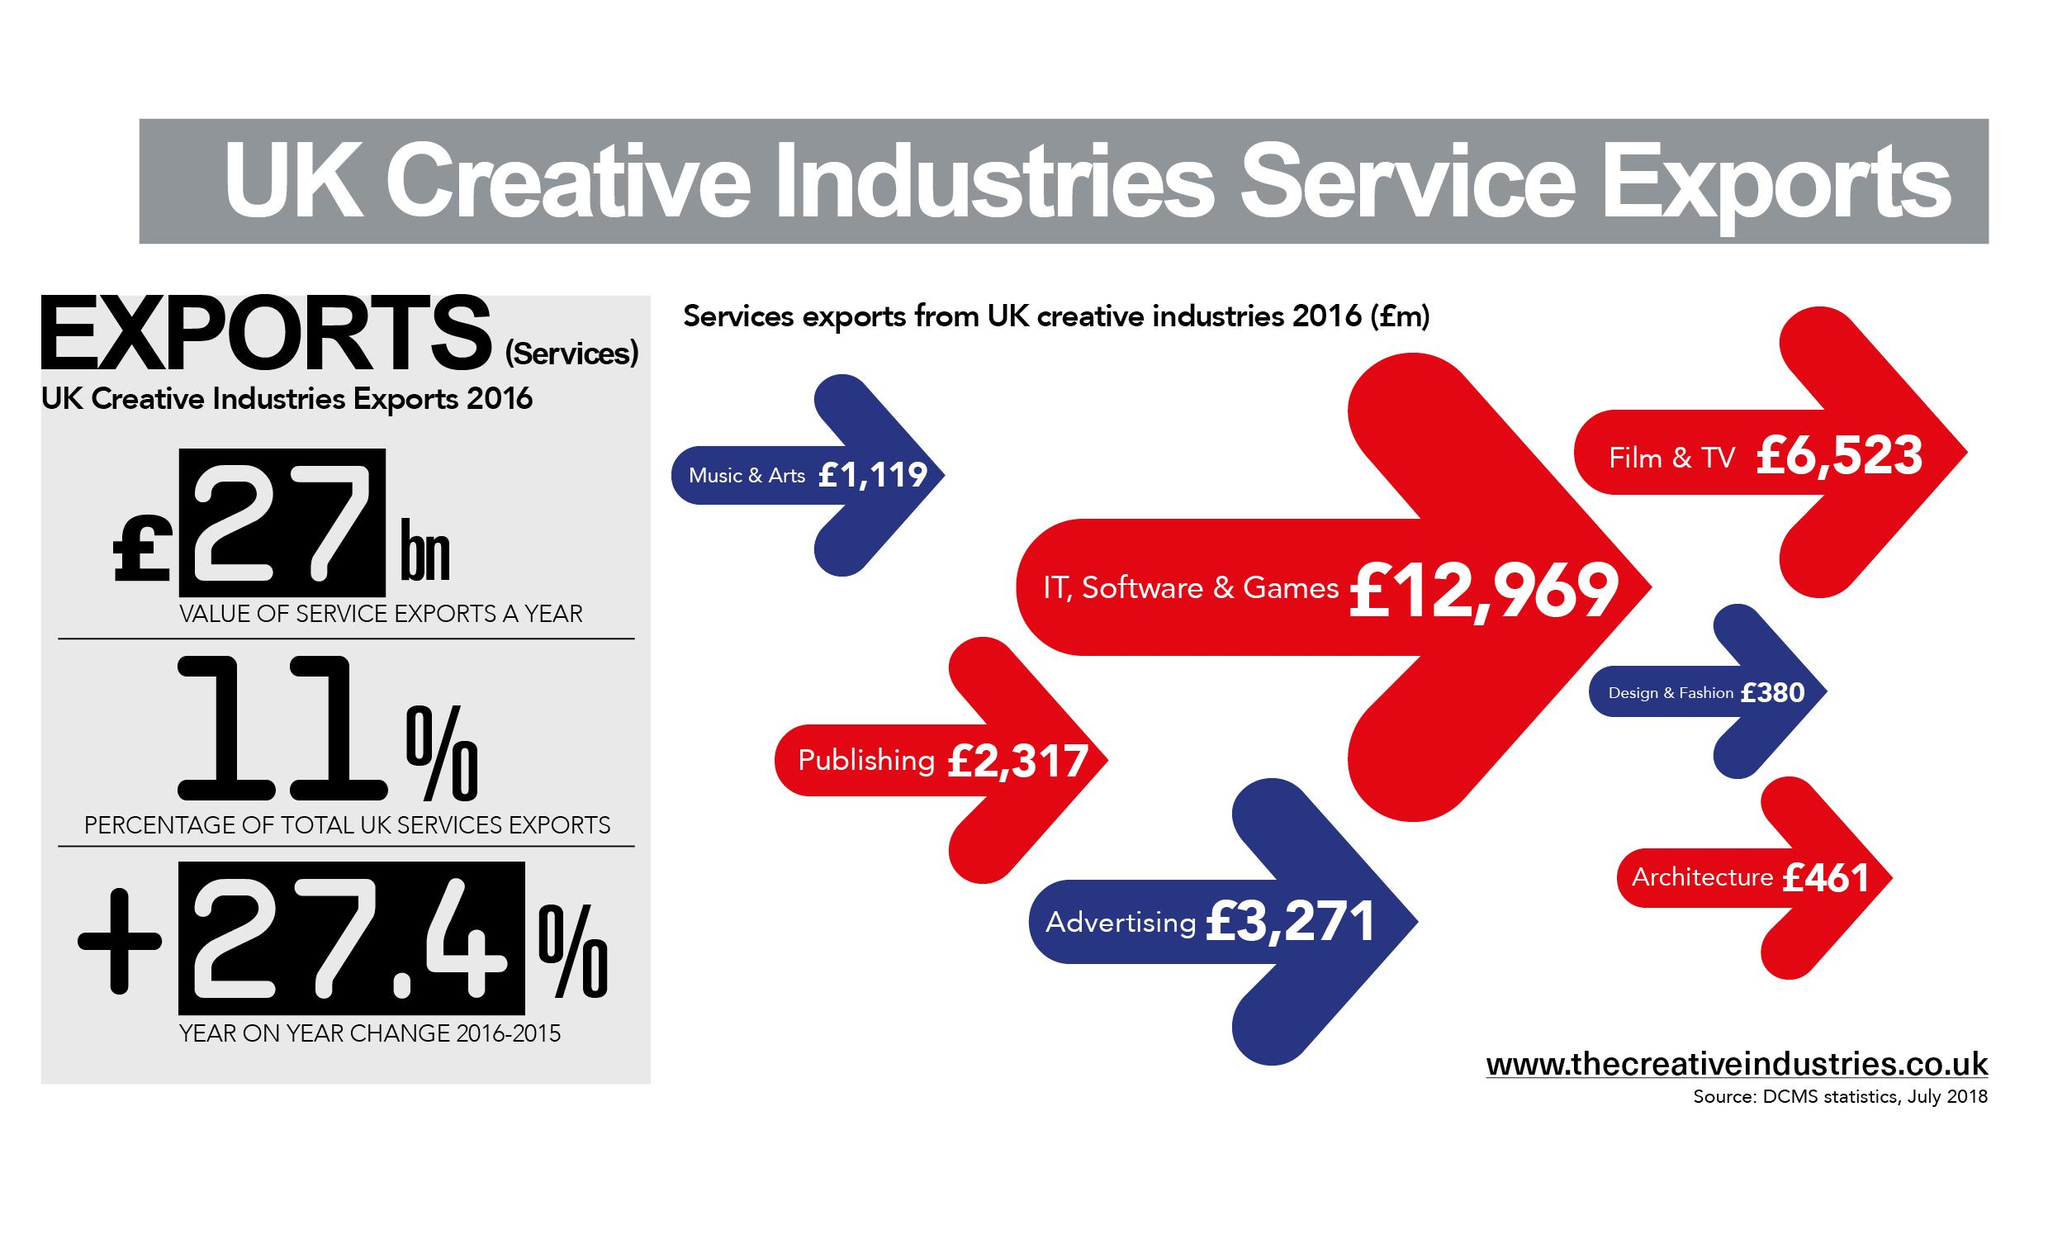Highlight a few significant elements in this photo. Film and TV has the second highest value of service exports, surpassed only by IT, software, and games. The total value of exports from other creative industries, excluding IT, software & games, is 14,071 pounds. 